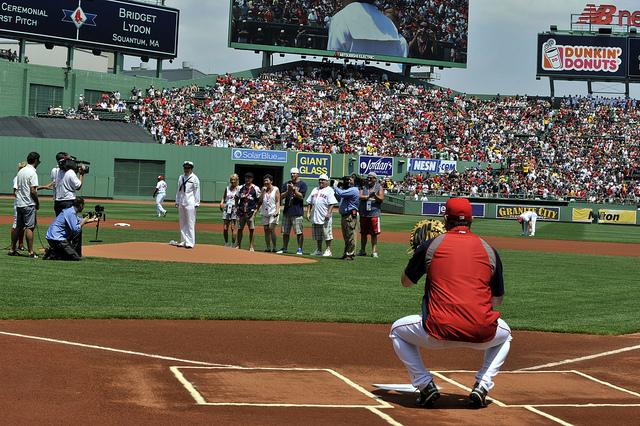What type of pitch is this? baseball diamond 